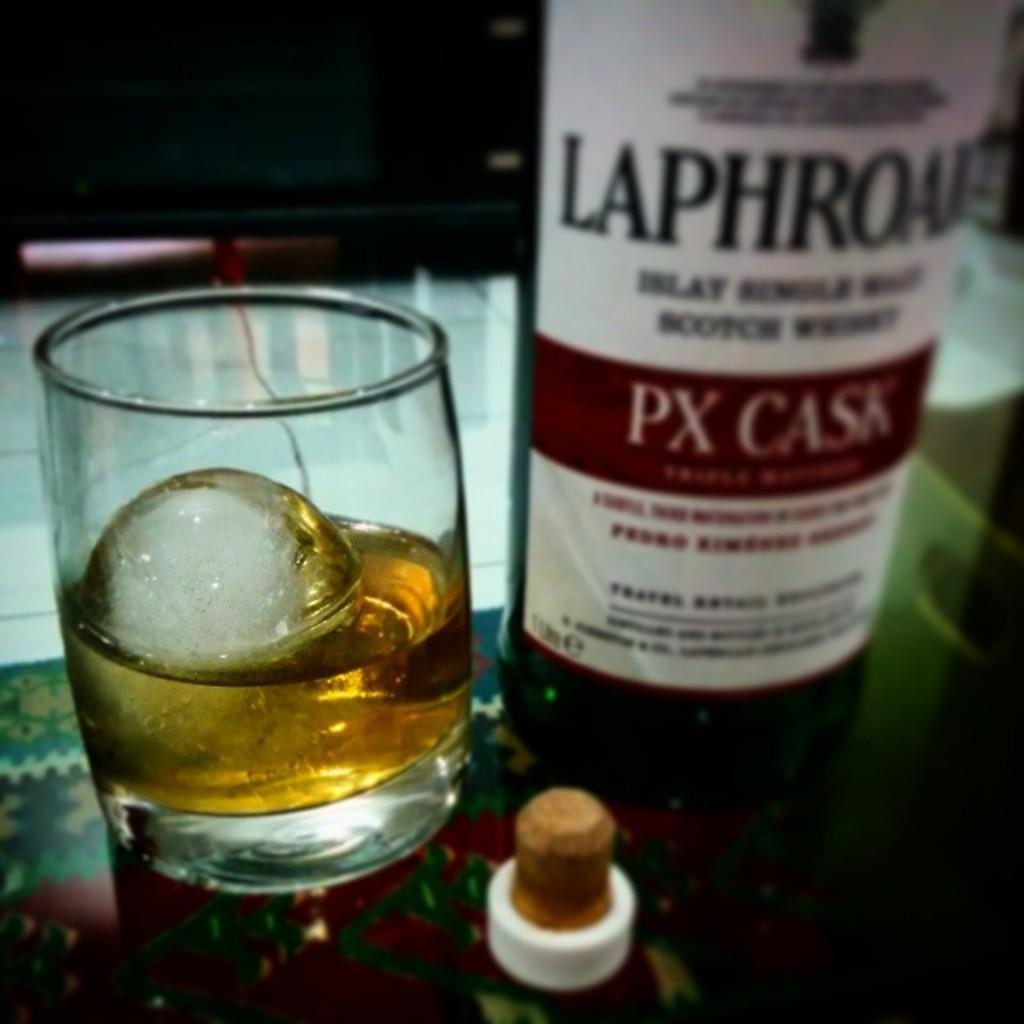<image>
Give a short and clear explanation of the subsequent image. An open bottle of Laphroai scotch with a half full glass of scotch on the rocks and the cap of the bottle in the middle. 